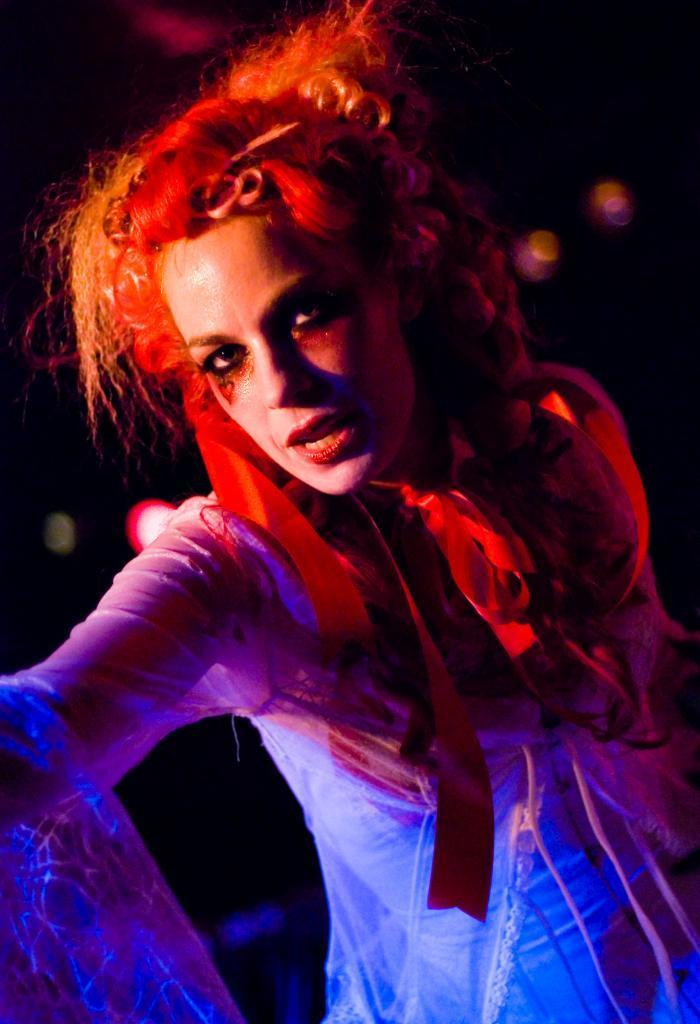Who is the main subject in the image? There is a woman in the image. What is the woman wearing? The woman is wearing a white top. Can you describe the background of the image? The background of the image is blurry. How many pizzas are being served on the plane in the image? There is no plane or pizzas present in the image; it features a woman wearing a white top with a blurry background. 